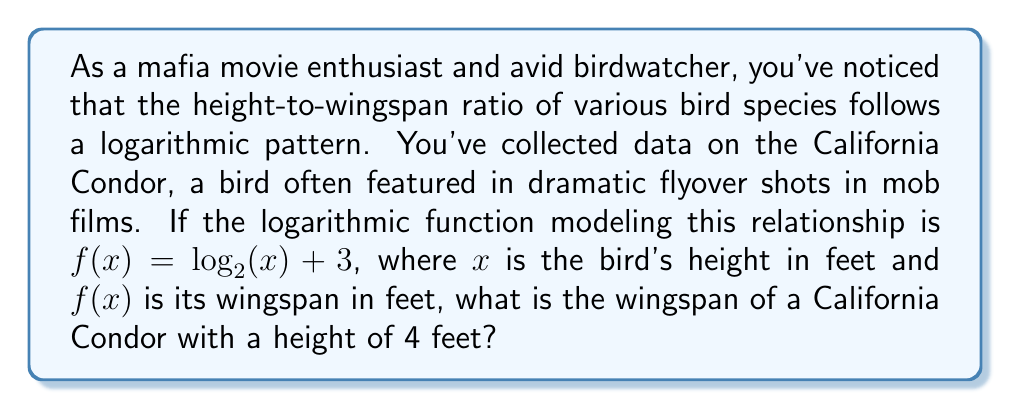Provide a solution to this math problem. Let's approach this step-by-step:

1) We're given the logarithmic function: $f(x) = \log_2(x) + 3$

2) In this function:
   - $x$ represents the bird's height in feet
   - $f(x)$ represents the bird's wingspan in feet

3) We need to find $f(4)$, as the California Condor's height is given as 4 feet.

4) Let's substitute $x = 4$ into our function:

   $f(4) = \log_2(4) + 3$

5) Now, let's evaluate $\log_2(4)$:
   
   $\log_2(4) = 2$ (because $2^2 = 4$)

6) Substituting this back into our equation:

   $f(4) = 2 + 3 = 5$

Therefore, the wingspan of a California Condor with a height of 4 feet is 5 feet.
Answer: The wingspan of the California Condor is 5 feet. 